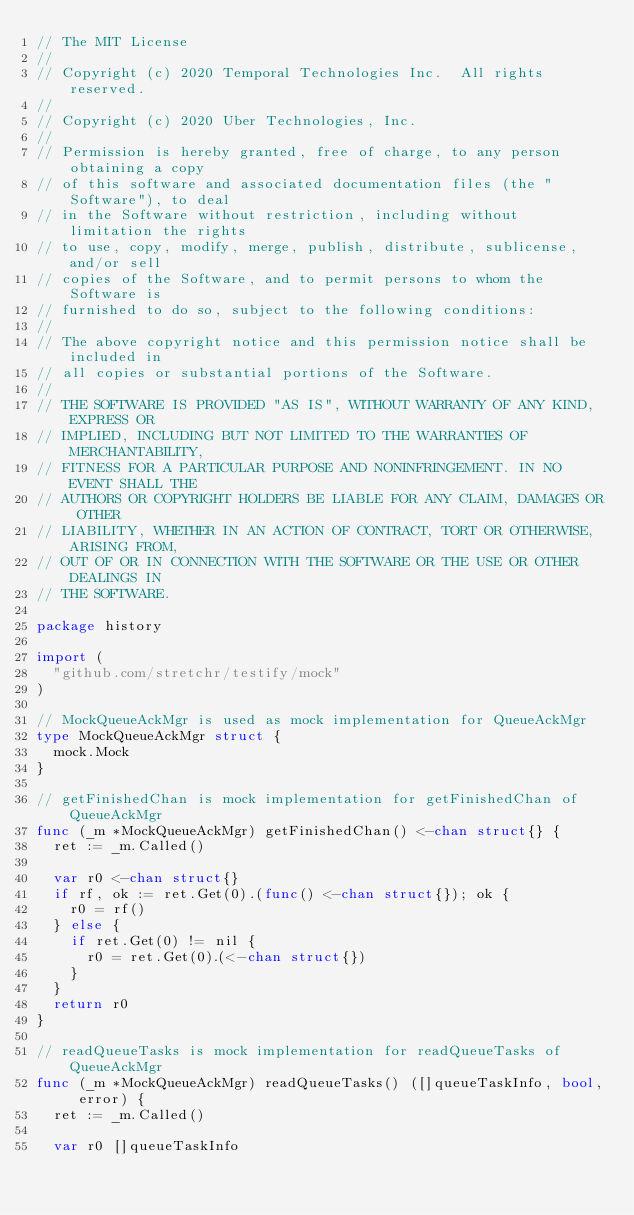Convert code to text. <code><loc_0><loc_0><loc_500><loc_500><_Go_>// The MIT License
//
// Copyright (c) 2020 Temporal Technologies Inc.  All rights reserved.
//
// Copyright (c) 2020 Uber Technologies, Inc.
//
// Permission is hereby granted, free of charge, to any person obtaining a copy
// of this software and associated documentation files (the "Software"), to deal
// in the Software without restriction, including without limitation the rights
// to use, copy, modify, merge, publish, distribute, sublicense, and/or sell
// copies of the Software, and to permit persons to whom the Software is
// furnished to do so, subject to the following conditions:
//
// The above copyright notice and this permission notice shall be included in
// all copies or substantial portions of the Software.
//
// THE SOFTWARE IS PROVIDED "AS IS", WITHOUT WARRANTY OF ANY KIND, EXPRESS OR
// IMPLIED, INCLUDING BUT NOT LIMITED TO THE WARRANTIES OF MERCHANTABILITY,
// FITNESS FOR A PARTICULAR PURPOSE AND NONINFRINGEMENT. IN NO EVENT SHALL THE
// AUTHORS OR COPYRIGHT HOLDERS BE LIABLE FOR ANY CLAIM, DAMAGES OR OTHER
// LIABILITY, WHETHER IN AN ACTION OF CONTRACT, TORT OR OTHERWISE, ARISING FROM,
// OUT OF OR IN CONNECTION WITH THE SOFTWARE OR THE USE OR OTHER DEALINGS IN
// THE SOFTWARE.

package history

import (
	"github.com/stretchr/testify/mock"
)

// MockQueueAckMgr is used as mock implementation for QueueAckMgr
type MockQueueAckMgr struct {
	mock.Mock
}

// getFinishedChan is mock implementation for getFinishedChan of QueueAckMgr
func (_m *MockQueueAckMgr) getFinishedChan() <-chan struct{} {
	ret := _m.Called()

	var r0 <-chan struct{}
	if rf, ok := ret.Get(0).(func() <-chan struct{}); ok {
		r0 = rf()
	} else {
		if ret.Get(0) != nil {
			r0 = ret.Get(0).(<-chan struct{})
		}
	}
	return r0
}

// readQueueTasks is mock implementation for readQueueTasks of QueueAckMgr
func (_m *MockQueueAckMgr) readQueueTasks() ([]queueTaskInfo, bool, error) {
	ret := _m.Called()

	var r0 []queueTaskInfo</code> 